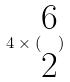Convert formula to latex. <formula><loc_0><loc_0><loc_500><loc_500>4 \times ( \begin{matrix} 6 \\ 2 \end{matrix} )</formula> 